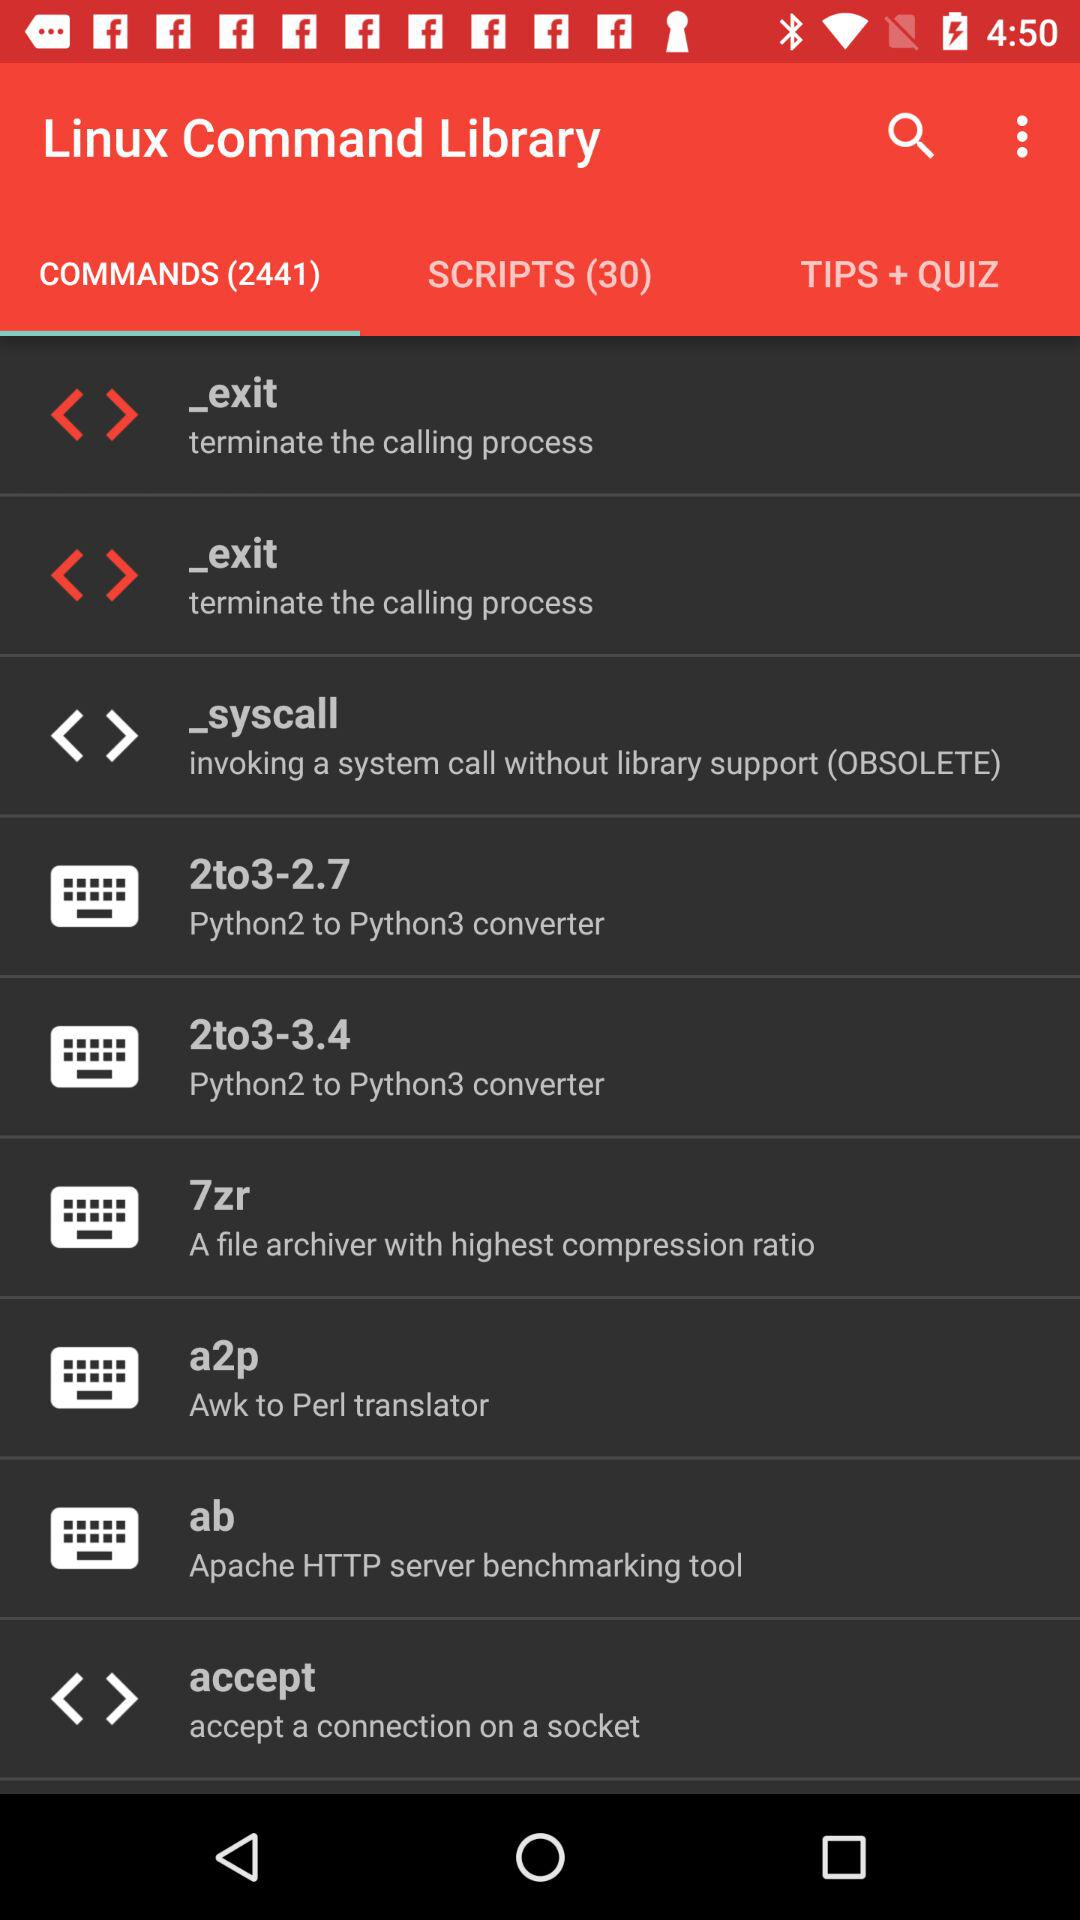What is the application name? The application name is "Linux Command Library". 